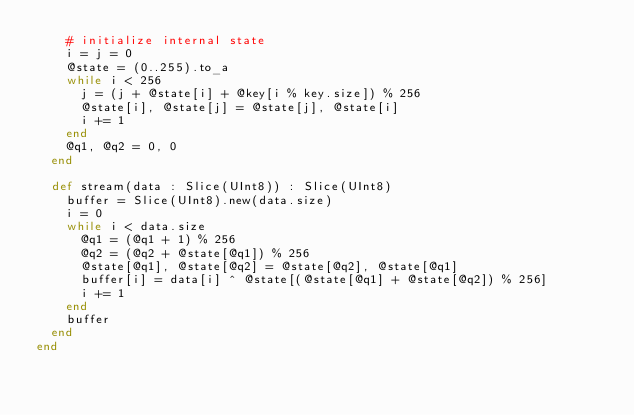<code> <loc_0><loc_0><loc_500><loc_500><_Crystal_>    # initialize internal state
    i = j = 0
    @state = (0..255).to_a
    while i < 256
      j = (j + @state[i] + @key[i % key.size]) % 256
      @state[i], @state[j] = @state[j], @state[i]
      i += 1
    end
    @q1, @q2 = 0, 0
  end

  def stream(data : Slice(UInt8)) : Slice(UInt8)
    buffer = Slice(UInt8).new(data.size)
    i = 0
    while i < data.size
      @q1 = (@q1 + 1) % 256
      @q2 = (@q2 + @state[@q1]) % 256
      @state[@q1], @state[@q2] = @state[@q2], @state[@q1]
      buffer[i] = data[i] ^ @state[(@state[@q1] + @state[@q2]) % 256]
      i += 1
    end
    buffer
  end
end
</code> 